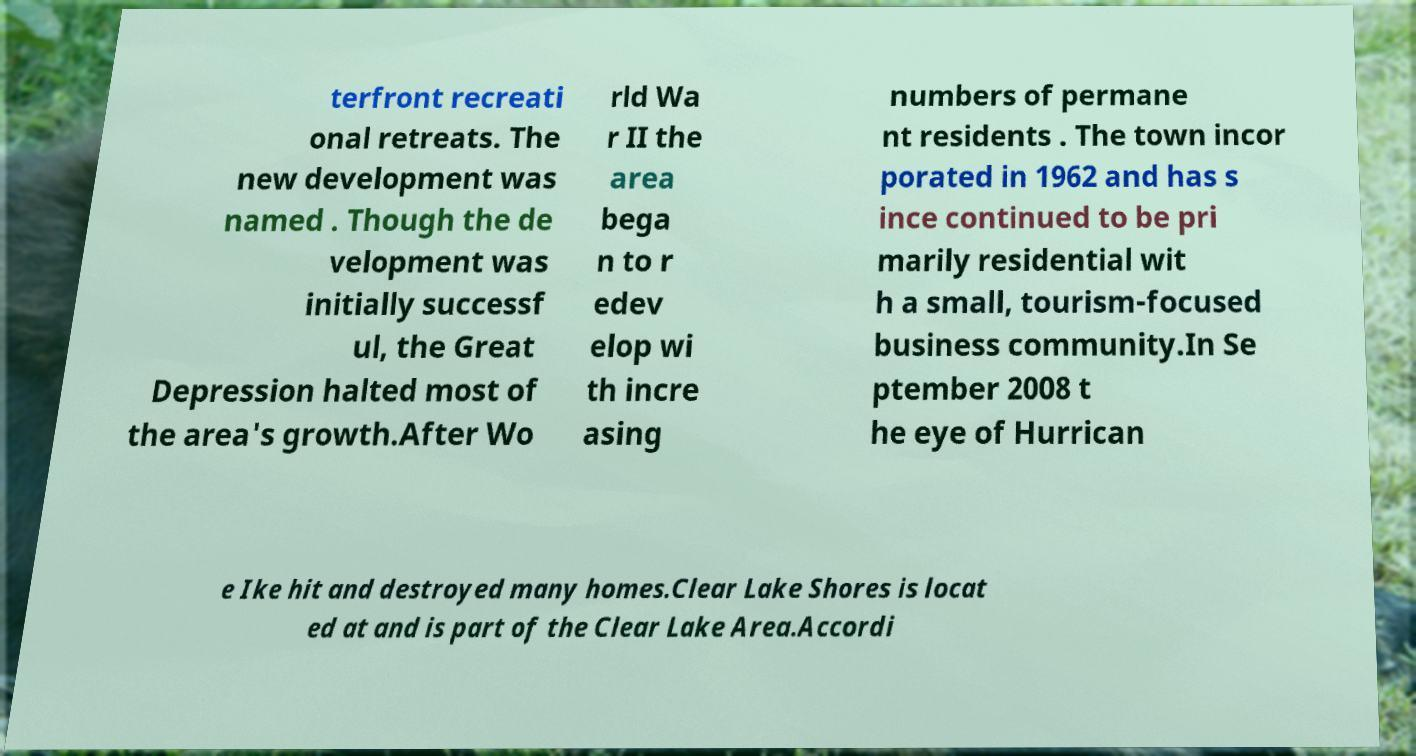Could you assist in decoding the text presented in this image and type it out clearly? terfront recreati onal retreats. The new development was named . Though the de velopment was initially successf ul, the Great Depression halted most of the area's growth.After Wo rld Wa r II the area bega n to r edev elop wi th incre asing numbers of permane nt residents . The town incor porated in 1962 and has s ince continued to be pri marily residential wit h a small, tourism-focused business community.In Se ptember 2008 t he eye of Hurrican e Ike hit and destroyed many homes.Clear Lake Shores is locat ed at and is part of the Clear Lake Area.Accordi 